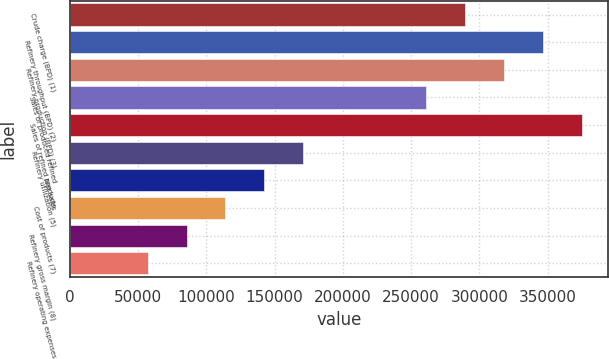Convert chart to OTSL. <chart><loc_0><loc_0><loc_500><loc_500><bar_chart><fcel>Crude charge (BPD) (1)<fcel>Refinery throughput (BPD) (2)<fcel>Refinery production (BPD) (3)<fcel>Sales of produced refined<fcel>Sales of refined products<fcel>Refinery utilization (5)<fcel>Net sales<fcel>Cost of products (7)<fcel>Refinery gross margin (8)<fcel>Refinery operating expenses<nl><fcel>289708<fcel>346723<fcel>318215<fcel>261200<fcel>375231<fcel>171049<fcel>142542<fcel>114034<fcel>85526.3<fcel>57018.6<nl></chart> 